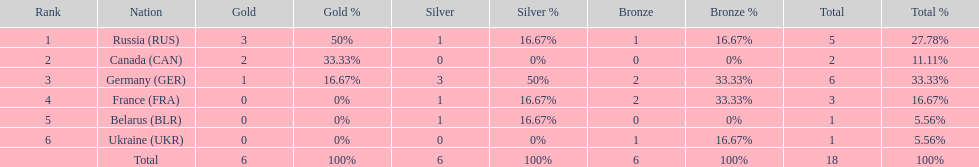What country had the most medals total at the the 1994 winter olympics biathlon? Germany (GER). 